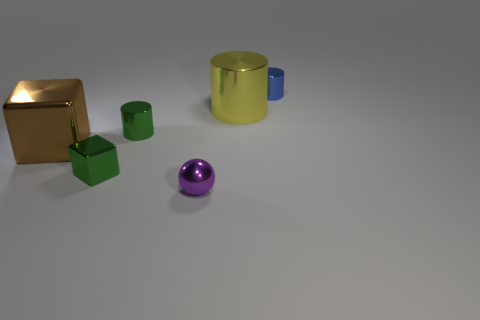What is the size of the blue metal thing that is the same shape as the large yellow object?
Keep it short and to the point. Small. What number of brown objects are tiny metal cylinders or shiny objects?
Your response must be concise. 1. There is a metal cylinder that is behind the big cylinder; how many cylinders are in front of it?
Keep it short and to the point. 2. What number of other things are the same shape as the purple object?
Offer a terse response. 0. How many metallic cylinders have the same color as the tiny shiny sphere?
Offer a terse response. 0. The large cylinder that is the same material as the tiny ball is what color?
Give a very brief answer. Yellow. Is there a cylinder of the same size as the purple object?
Your response must be concise. Yes. Is the number of tiny blue metal cylinders behind the small purple sphere greater than the number of large brown cubes that are in front of the brown thing?
Ensure brevity in your answer.  Yes. Is the green thing behind the brown shiny block made of the same material as the thing behind the big yellow shiny object?
Your answer should be very brief. Yes. What is the shape of the purple shiny thing that is the same size as the green shiny cylinder?
Keep it short and to the point. Sphere. 